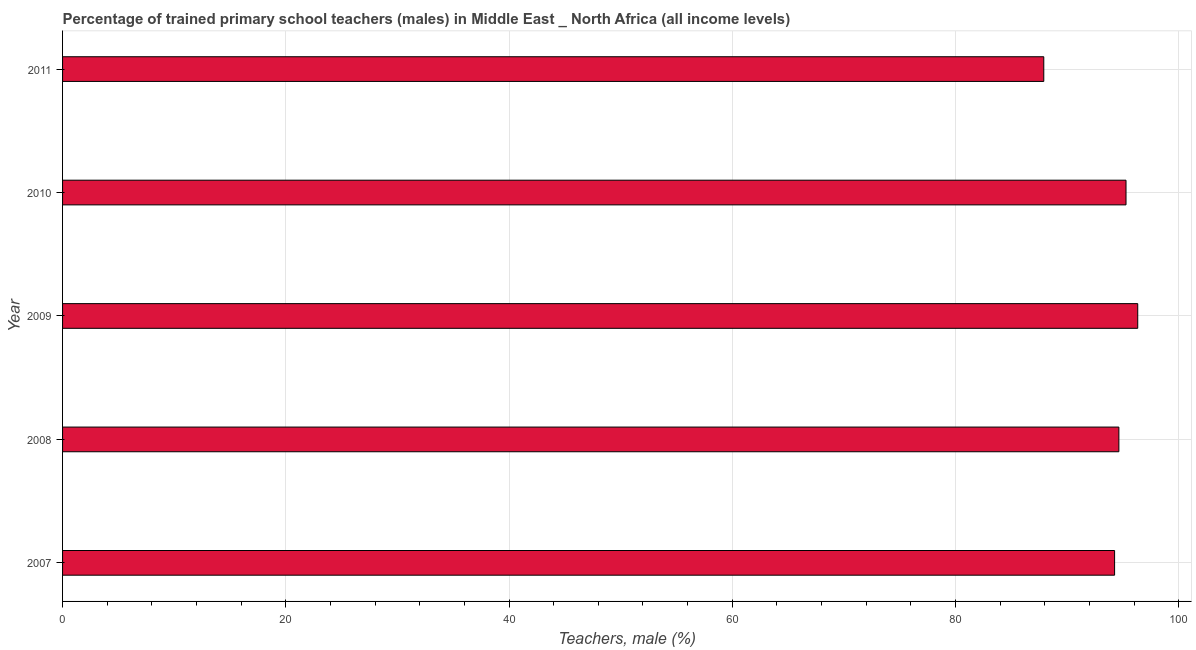What is the title of the graph?
Provide a succinct answer. Percentage of trained primary school teachers (males) in Middle East _ North Africa (all income levels). What is the label or title of the X-axis?
Ensure brevity in your answer.  Teachers, male (%). What is the label or title of the Y-axis?
Give a very brief answer. Year. What is the percentage of trained male teachers in 2011?
Your answer should be compact. 87.91. Across all years, what is the maximum percentage of trained male teachers?
Give a very brief answer. 96.33. Across all years, what is the minimum percentage of trained male teachers?
Offer a terse response. 87.91. In which year was the percentage of trained male teachers minimum?
Provide a succinct answer. 2011. What is the sum of the percentage of trained male teachers?
Provide a short and direct response. 468.43. What is the difference between the percentage of trained male teachers in 2008 and 2011?
Provide a succinct answer. 6.73. What is the average percentage of trained male teachers per year?
Your answer should be very brief. 93.69. What is the median percentage of trained male teachers?
Keep it short and to the point. 94.64. Do a majority of the years between 2008 and 2007 (inclusive) have percentage of trained male teachers greater than 40 %?
Ensure brevity in your answer.  No. What is the ratio of the percentage of trained male teachers in 2008 to that in 2010?
Your answer should be very brief. 0.99. Is the percentage of trained male teachers in 2007 less than that in 2010?
Make the answer very short. Yes. Is the difference between the percentage of trained male teachers in 2008 and 2010 greater than the difference between any two years?
Your response must be concise. No. What is the difference between the highest and the lowest percentage of trained male teachers?
Keep it short and to the point. 8.42. In how many years, is the percentage of trained male teachers greater than the average percentage of trained male teachers taken over all years?
Provide a short and direct response. 4. How many bars are there?
Provide a short and direct response. 5. Are all the bars in the graph horizontal?
Make the answer very short. Yes. Are the values on the major ticks of X-axis written in scientific E-notation?
Your answer should be compact. No. What is the Teachers, male (%) of 2007?
Ensure brevity in your answer.  94.26. What is the Teachers, male (%) in 2008?
Your response must be concise. 94.64. What is the Teachers, male (%) of 2009?
Your answer should be compact. 96.33. What is the Teachers, male (%) in 2010?
Provide a short and direct response. 95.28. What is the Teachers, male (%) of 2011?
Keep it short and to the point. 87.91. What is the difference between the Teachers, male (%) in 2007 and 2008?
Offer a very short reply. -0.38. What is the difference between the Teachers, male (%) in 2007 and 2009?
Offer a very short reply. -2.07. What is the difference between the Teachers, male (%) in 2007 and 2010?
Your answer should be very brief. -1.02. What is the difference between the Teachers, male (%) in 2007 and 2011?
Your answer should be very brief. 6.35. What is the difference between the Teachers, male (%) in 2008 and 2009?
Offer a very short reply. -1.69. What is the difference between the Teachers, male (%) in 2008 and 2010?
Offer a very short reply. -0.64. What is the difference between the Teachers, male (%) in 2008 and 2011?
Offer a terse response. 6.73. What is the difference between the Teachers, male (%) in 2009 and 2010?
Your answer should be very brief. 1.05. What is the difference between the Teachers, male (%) in 2009 and 2011?
Make the answer very short. 8.42. What is the difference between the Teachers, male (%) in 2010 and 2011?
Provide a succinct answer. 7.37. What is the ratio of the Teachers, male (%) in 2007 to that in 2008?
Ensure brevity in your answer.  1. What is the ratio of the Teachers, male (%) in 2007 to that in 2009?
Provide a short and direct response. 0.98. What is the ratio of the Teachers, male (%) in 2007 to that in 2010?
Provide a succinct answer. 0.99. What is the ratio of the Teachers, male (%) in 2007 to that in 2011?
Your response must be concise. 1.07. What is the ratio of the Teachers, male (%) in 2008 to that in 2010?
Offer a very short reply. 0.99. What is the ratio of the Teachers, male (%) in 2008 to that in 2011?
Keep it short and to the point. 1.08. What is the ratio of the Teachers, male (%) in 2009 to that in 2010?
Your answer should be very brief. 1.01. What is the ratio of the Teachers, male (%) in 2009 to that in 2011?
Give a very brief answer. 1.1. What is the ratio of the Teachers, male (%) in 2010 to that in 2011?
Provide a short and direct response. 1.08. 